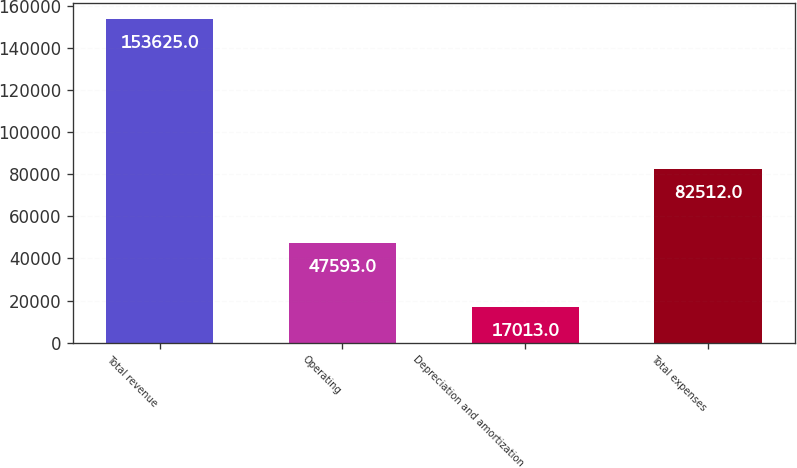Convert chart to OTSL. <chart><loc_0><loc_0><loc_500><loc_500><bar_chart><fcel>Total revenue<fcel>Operating<fcel>Depreciation and amortization<fcel>Total expenses<nl><fcel>153625<fcel>47593<fcel>17013<fcel>82512<nl></chart> 